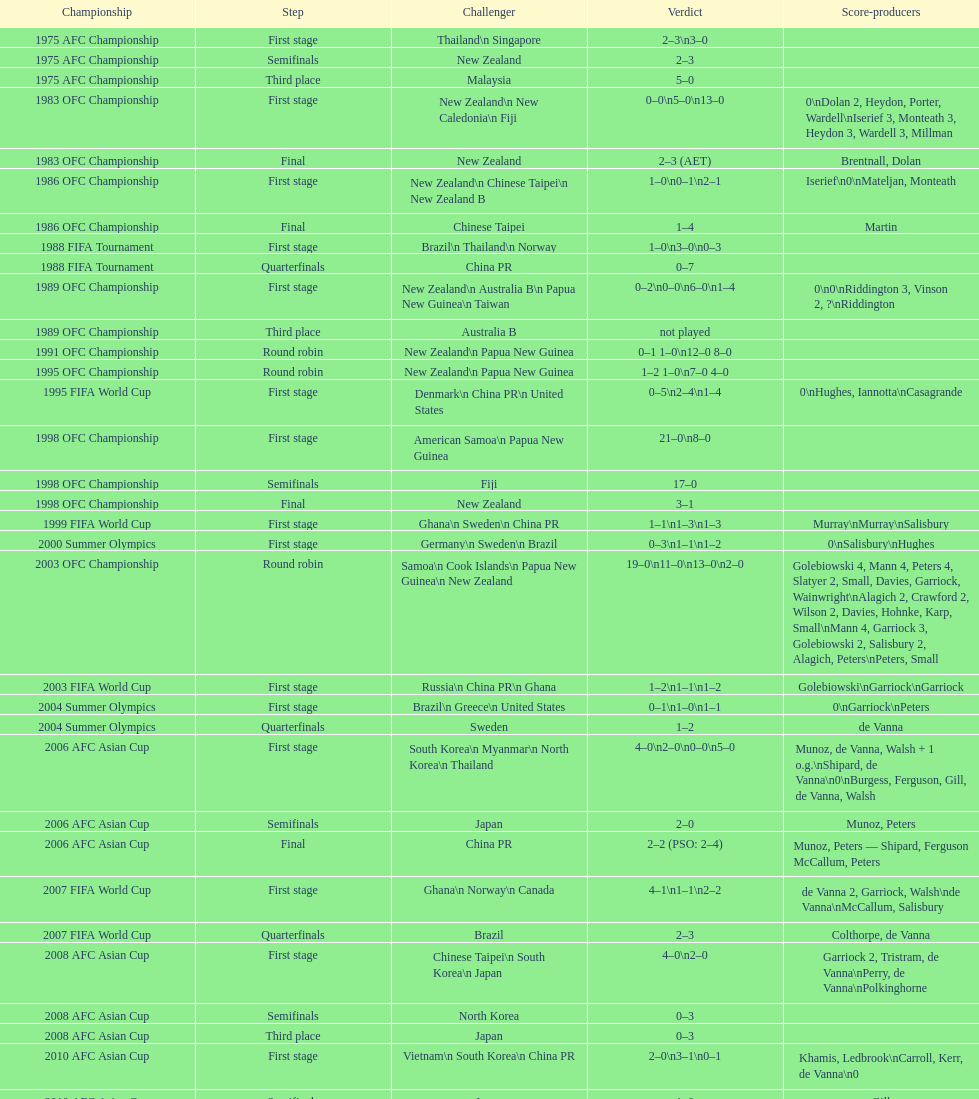What is the total number of competitions? 21. 